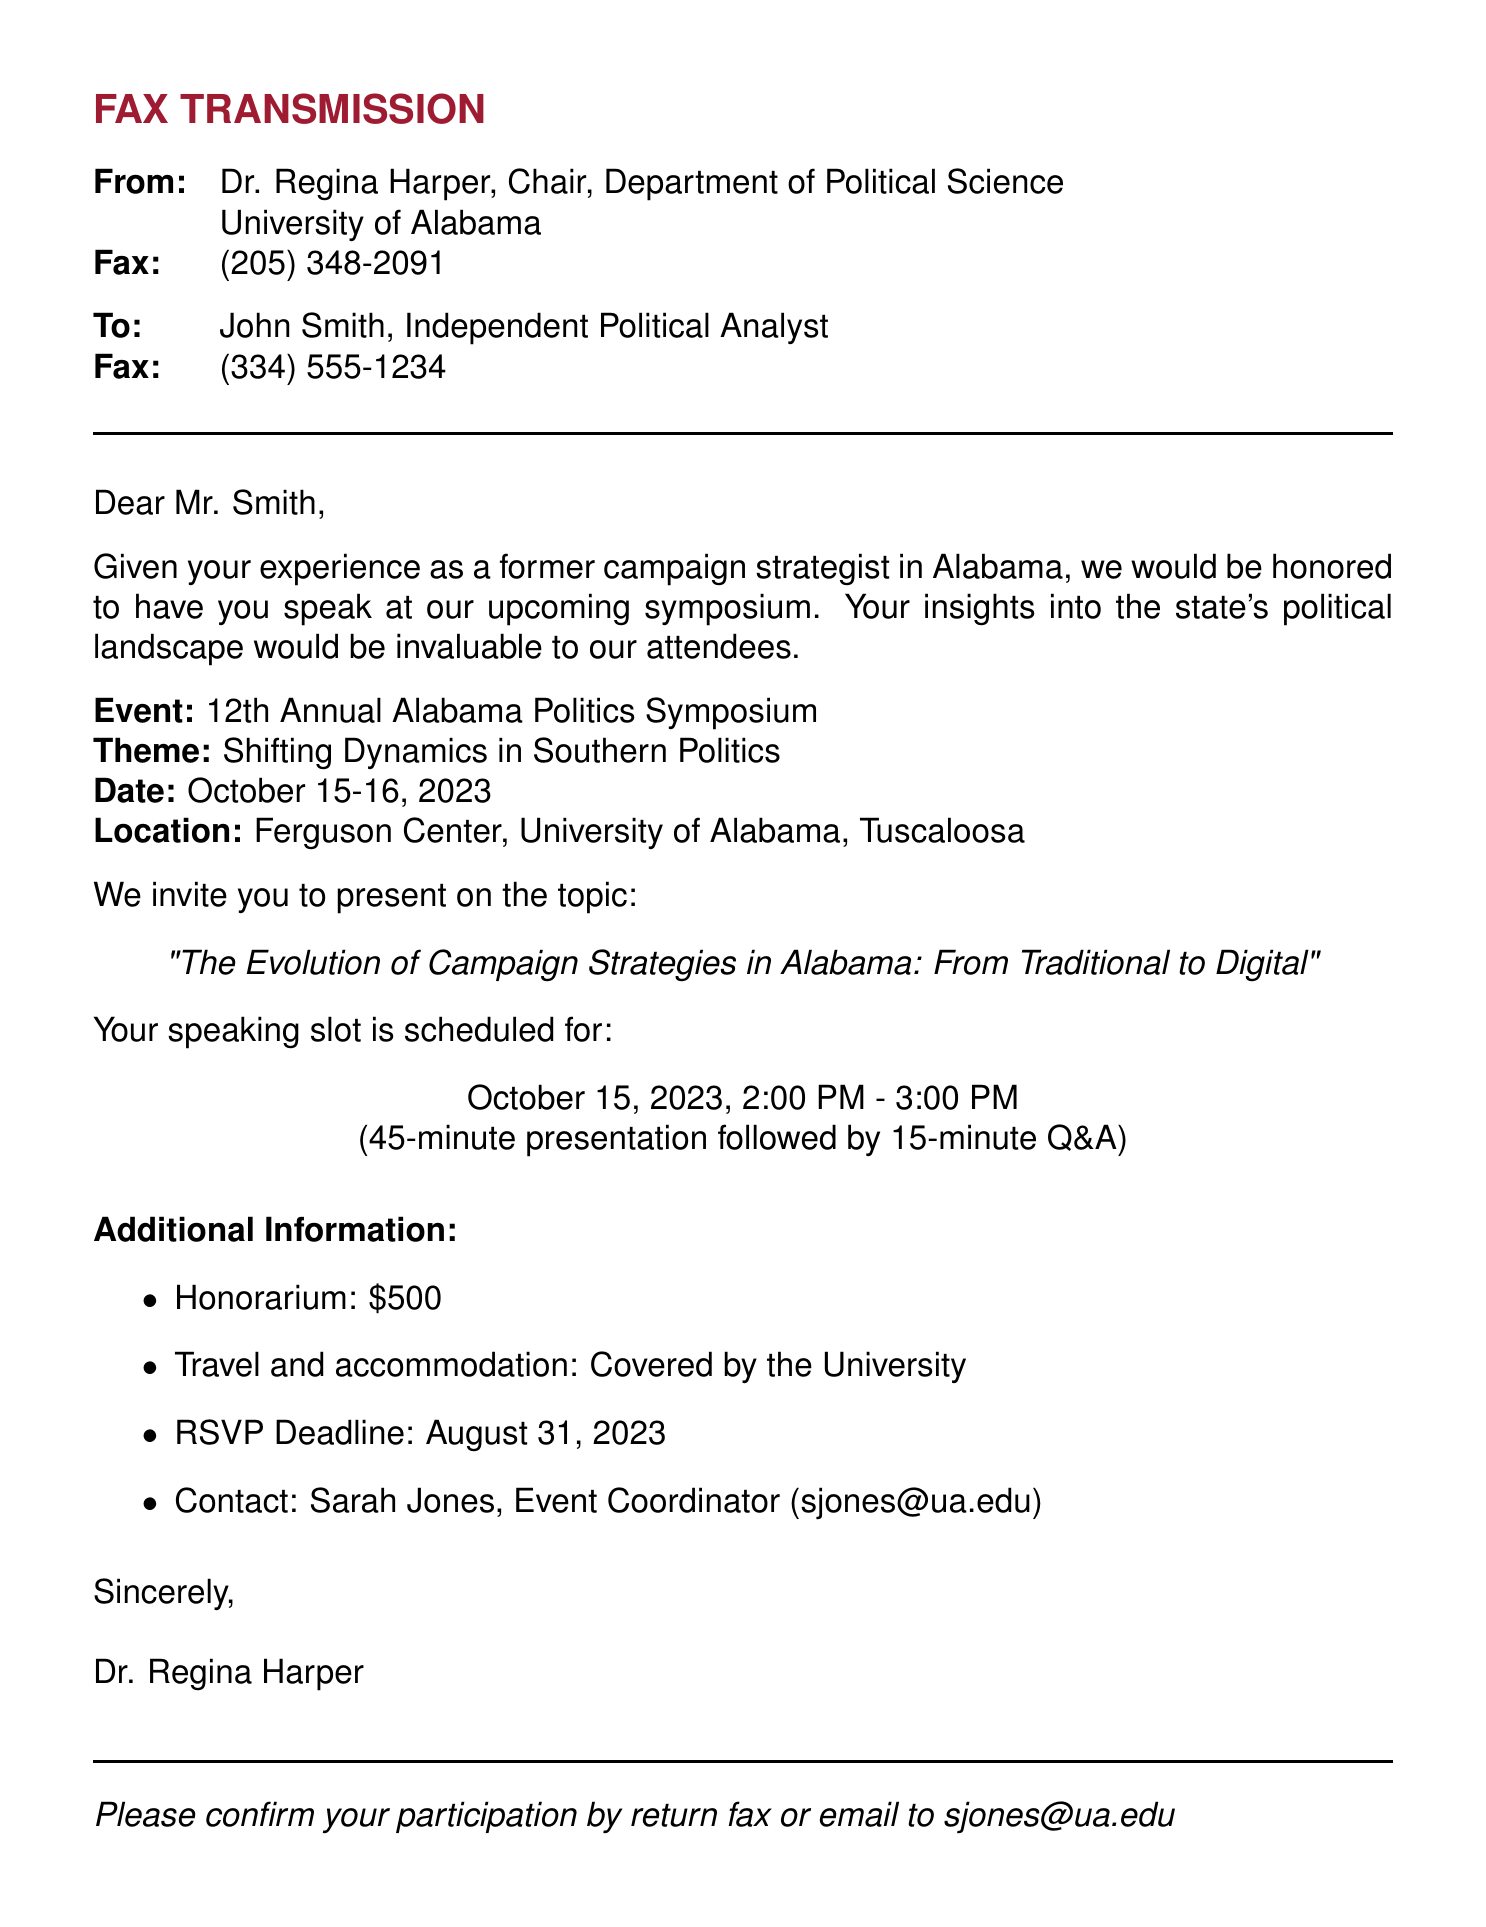What is the name of the event? The name of the event is explicitly mentioned in the document as the 12th Annual Alabama Politics Symposium.
Answer: 12th Annual Alabama Politics Symposium What is the scheduled speaking date for John Smith? The document clearly states the scheduled speaking date for John Smith as October 15, 2023.
Answer: October 15, 2023 Who is the contact person for the event? The document lists Sarah Jones as the contact person for the event.
Answer: Sarah Jones What is the honorarium amount for the speakers? The honorarium is specified in the document as $500.
Answer: $500 What is the RSVP deadline for the event? The document states that the RSVP deadline is August 31, 2023.
Answer: August 31, 2023 What are the main themes of the symposium? The theme of the symposium is presented in the document as Shifting Dynamics in Southern Politics.
Answer: Shifting Dynamics in Southern Politics How long is the speaking presentation scheduled for? The document details that the speaking presentation is scheduled for 45 minutes.
Answer: 45 minutes What type of document is this? This document serves as a fax transmission, as indicated at the top of the document.
Answer: Fax transmission 